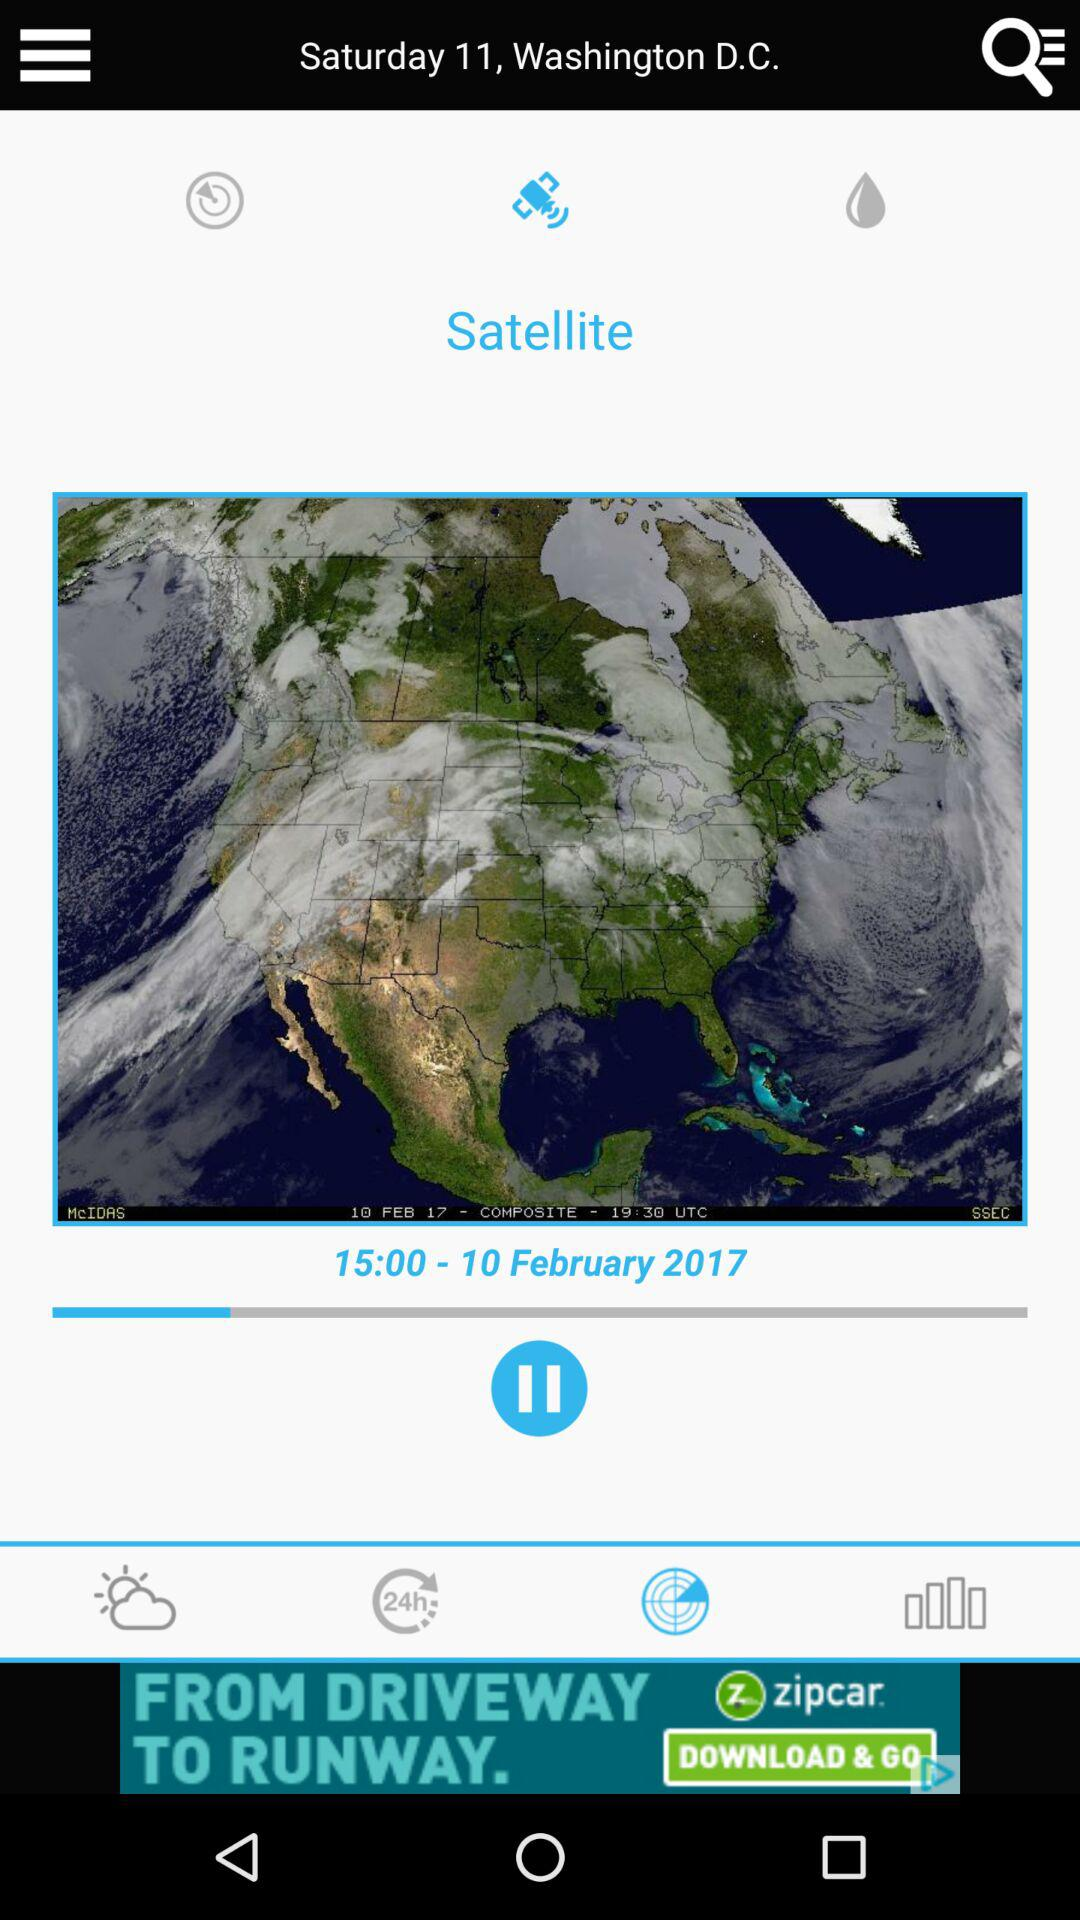At what time was the image taken by the satellite? The image was taken at 19:30 UTC. 